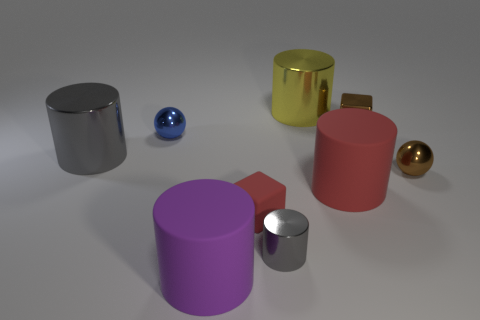What number of large objects have the same material as the small brown sphere?
Provide a succinct answer. 2. There is a block that is the same material as the small blue ball; what color is it?
Your answer should be very brief. Brown. There is a ball to the left of the matte object behind the red cube behind the tiny gray cylinder; what is its material?
Provide a succinct answer. Metal. There is a gray object in front of the matte cube; is its size the same as the tiny blue object?
Offer a terse response. Yes. What number of large objects are either green rubber objects or rubber objects?
Your answer should be very brief. 2. Is there a matte cube that has the same color as the tiny rubber thing?
Offer a terse response. No. The other rubber thing that is the same size as the purple thing is what shape?
Give a very brief answer. Cylinder. There is a big matte object in front of the small gray thing; does it have the same color as the matte cube?
Your answer should be compact. No. What number of things are either tiny shiny balls that are behind the big gray metal cylinder or gray metal balls?
Your response must be concise. 1. Is the number of big metallic things that are left of the blue metallic thing greater than the number of large yellow metal cylinders on the left side of the large purple rubber thing?
Your answer should be very brief. Yes. 